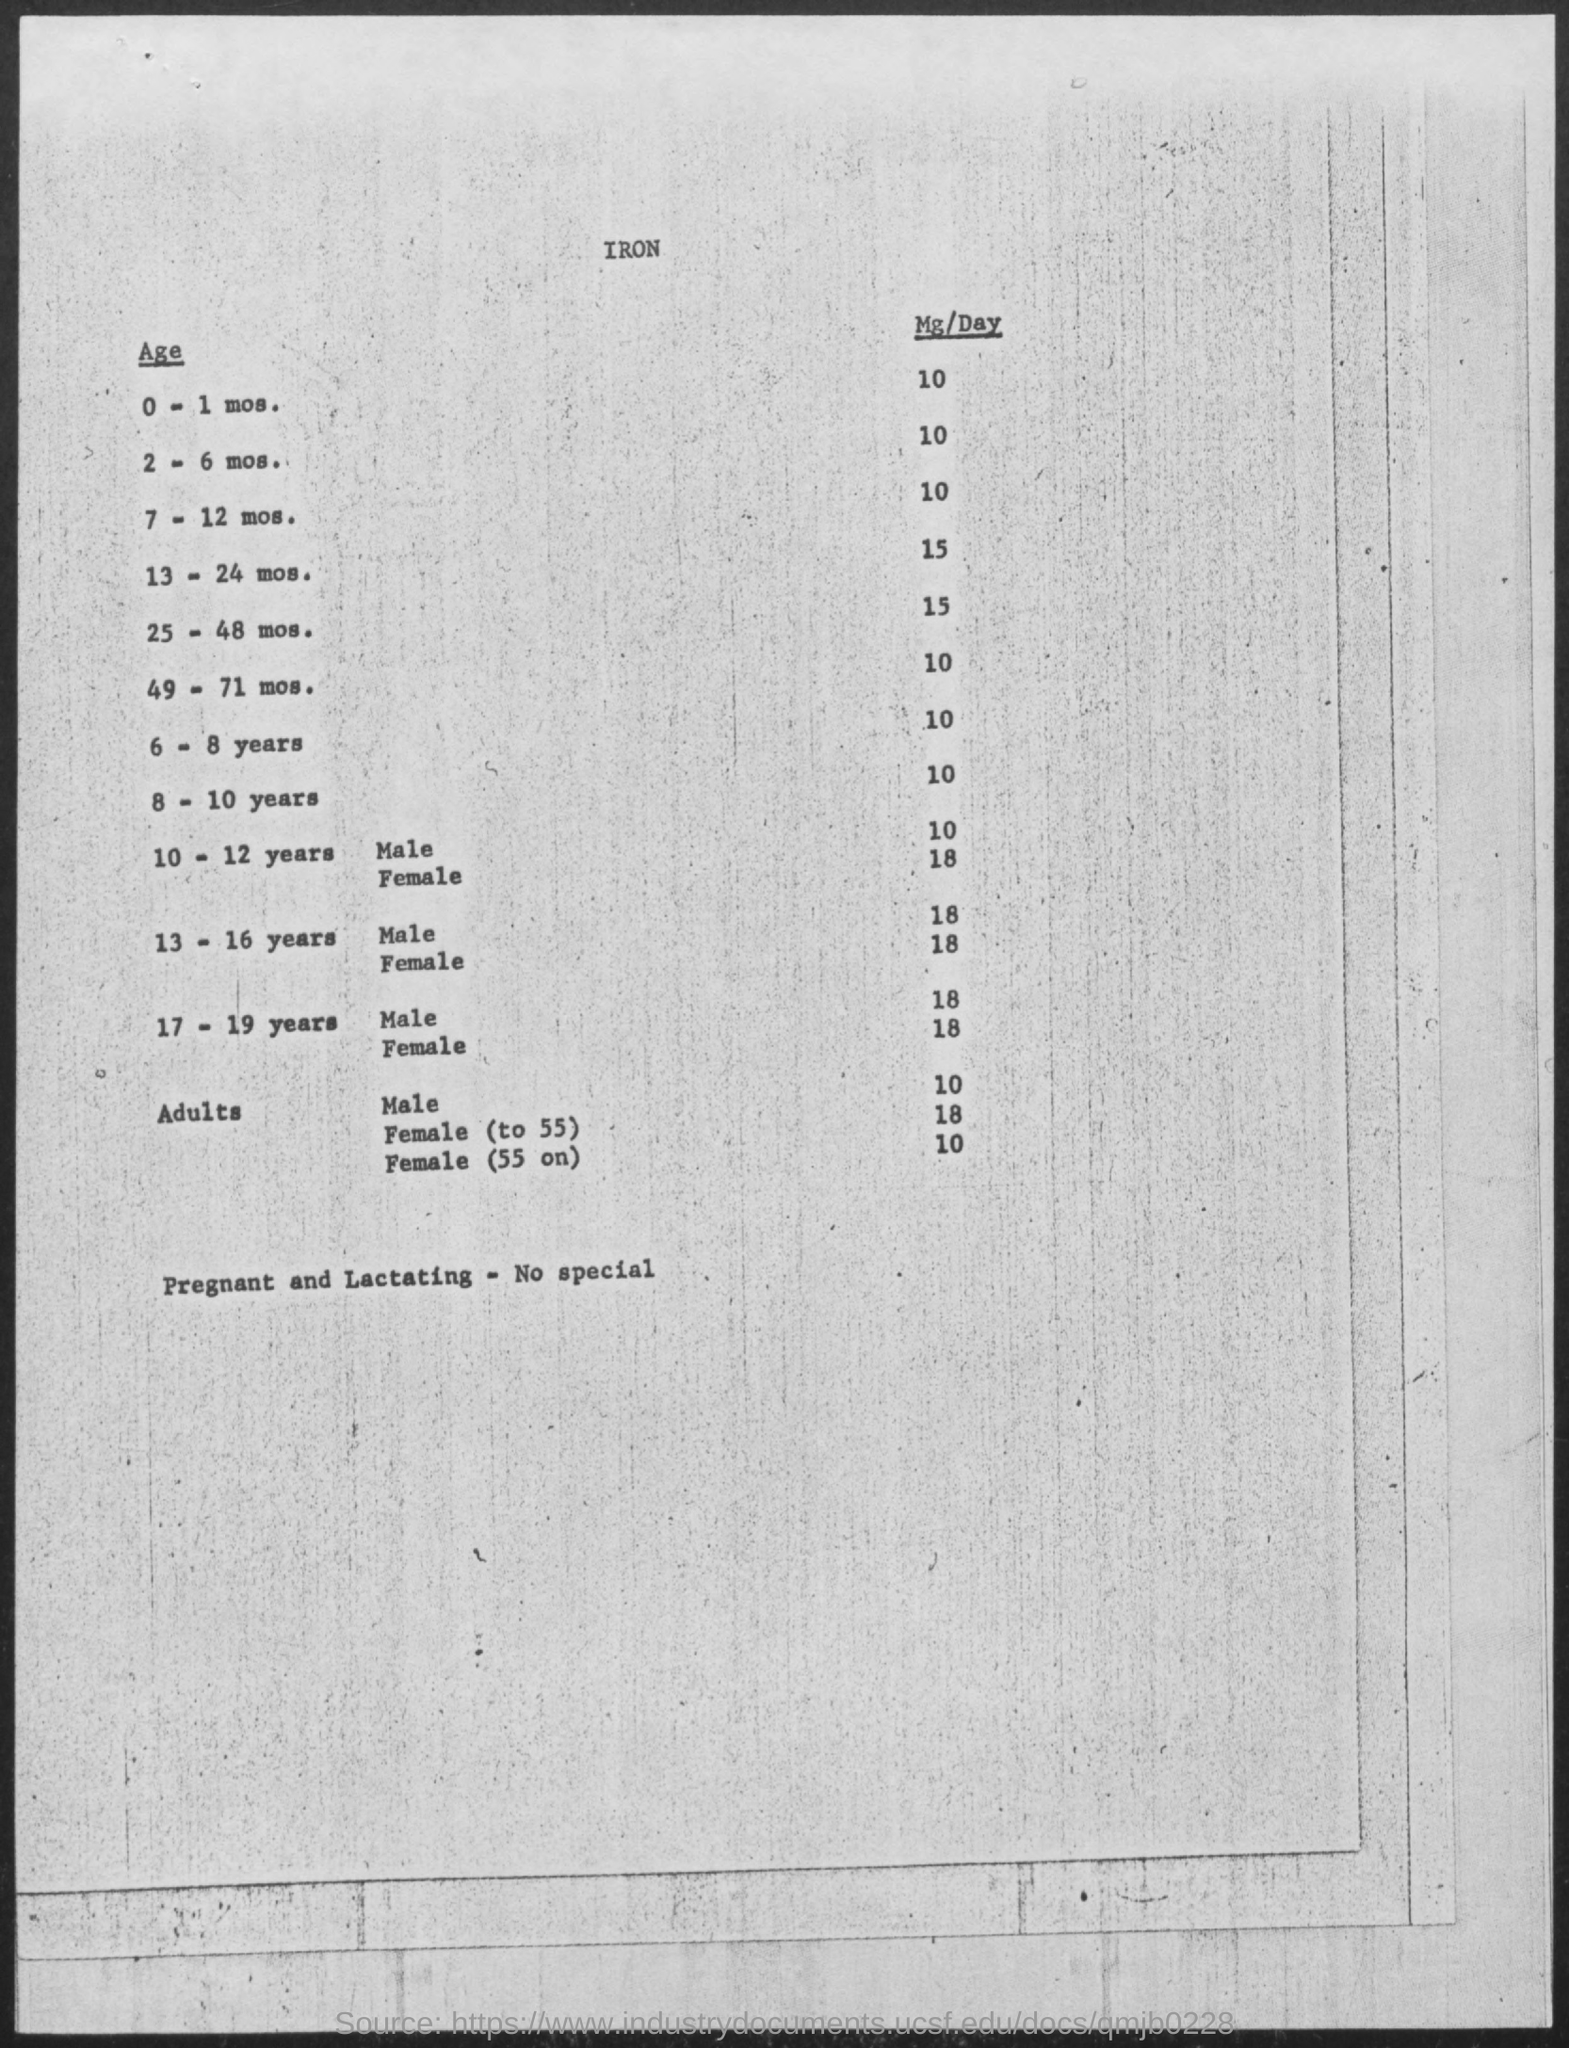Give some essential details in this illustration. The appropriate daily iron intake for individuals aged 49 to 71 months is 10 milligrams. The daily iron intake for children aged 6 to 8 years old is 10 milligrams. It is recommended that for individuals aged 2 to 6 months, the daily iron intake should be approximately 10 milligrams per day. The recommended daily intake of iron for a male aged 10-12 years is 10-12 milligrams per day. The recommended daily intake of iron for individuals aged 25-48 months is 15 milligrams per day. 